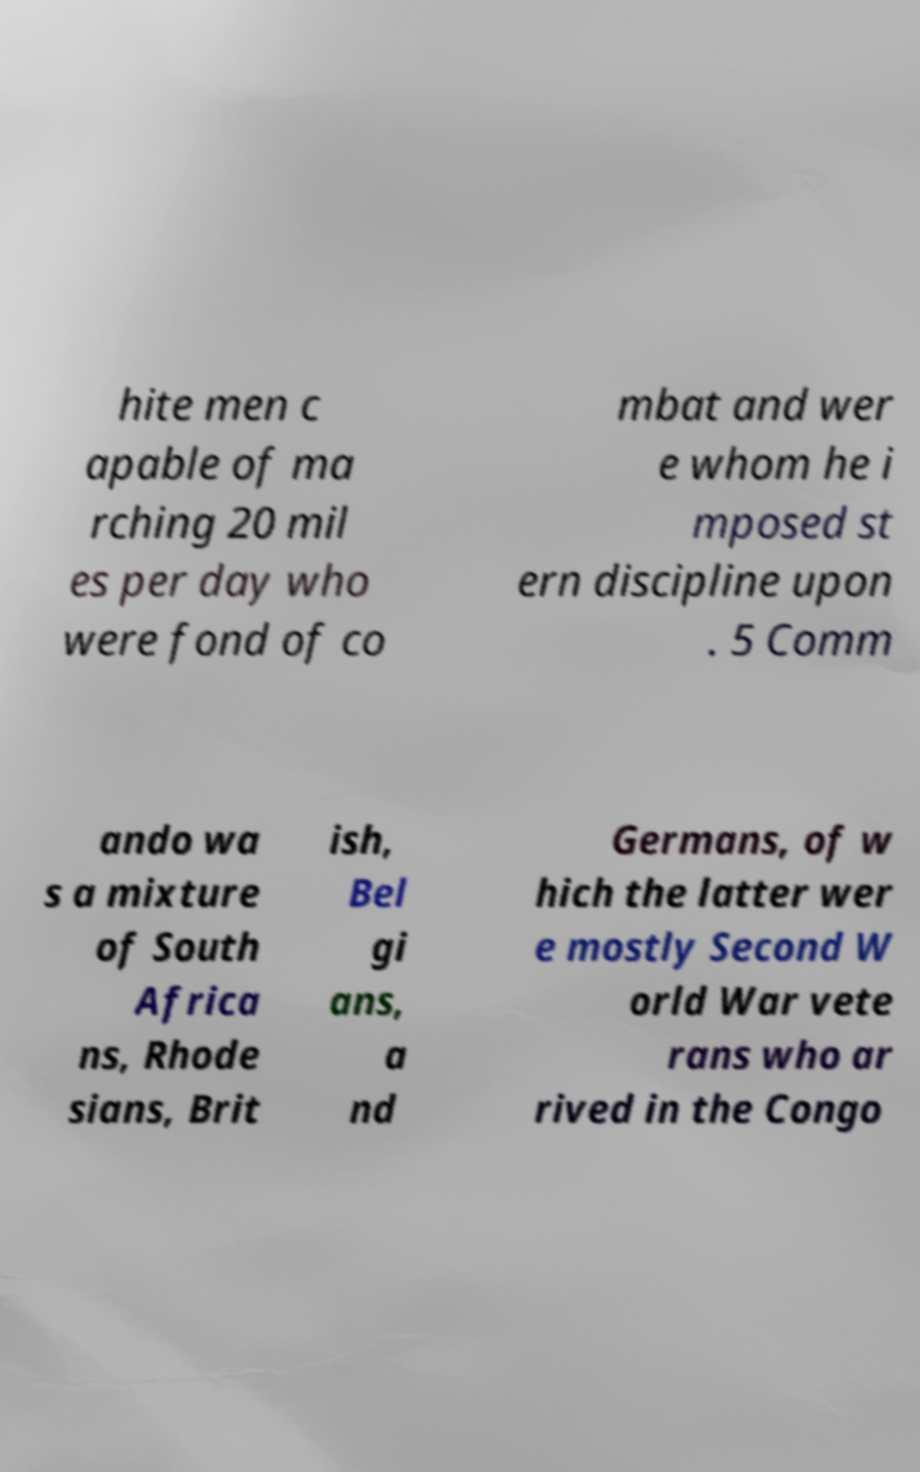I need the written content from this picture converted into text. Can you do that? hite men c apable of ma rching 20 mil es per day who were fond of co mbat and wer e whom he i mposed st ern discipline upon . 5 Comm ando wa s a mixture of South Africa ns, Rhode sians, Brit ish, Bel gi ans, a nd Germans, of w hich the latter wer e mostly Second W orld War vete rans who ar rived in the Congo 